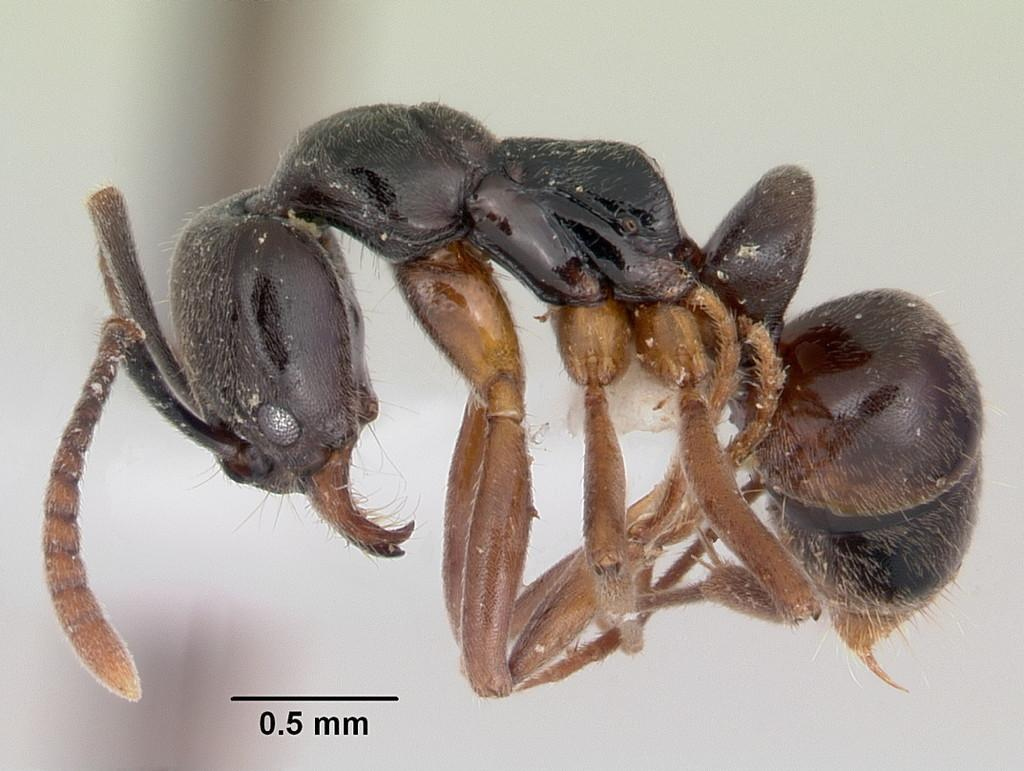What type of creature can be seen in the image? There is an insect in the image. How would you describe the background of the image? The background of the image is blurry. What is present at the bottom of the image? There is a line, numbers, and letters at the bottom of the image. What type of substance is being discovered in harmony by the insect in the image? There is no substance or discovery present in the image; it only features an insect and the mentioned background and bottom elements. 